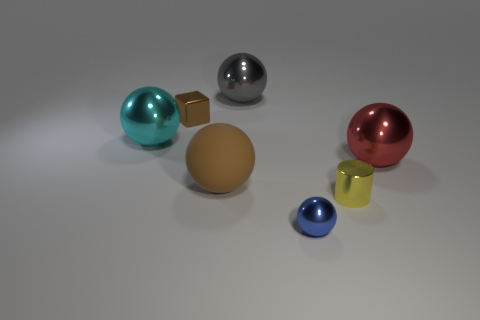Subtract all blue spheres. How many spheres are left? 4 Subtract all red balls. How many balls are left? 4 Subtract all yellow balls. Subtract all yellow cubes. How many balls are left? 5 Add 3 large cyan shiny objects. How many objects exist? 10 Subtract all blocks. How many objects are left? 6 Subtract 0 blue cylinders. How many objects are left? 7 Subtract all brown matte blocks. Subtract all large cyan things. How many objects are left? 6 Add 1 balls. How many balls are left? 6 Add 6 red metallic balls. How many red metallic balls exist? 7 